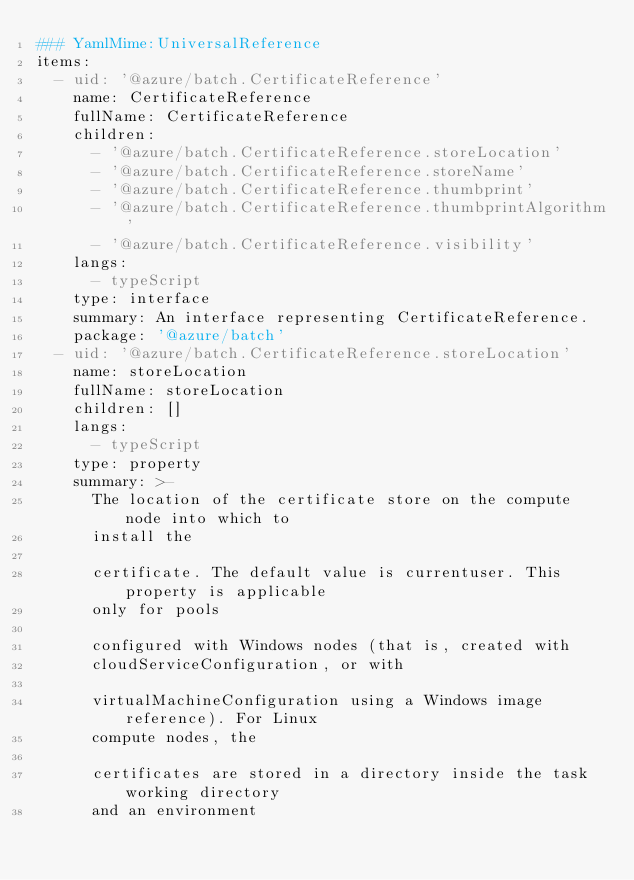Convert code to text. <code><loc_0><loc_0><loc_500><loc_500><_YAML_>### YamlMime:UniversalReference
items:
  - uid: '@azure/batch.CertificateReference'
    name: CertificateReference
    fullName: CertificateReference
    children:
      - '@azure/batch.CertificateReference.storeLocation'
      - '@azure/batch.CertificateReference.storeName'
      - '@azure/batch.CertificateReference.thumbprint'
      - '@azure/batch.CertificateReference.thumbprintAlgorithm'
      - '@azure/batch.CertificateReference.visibility'
    langs:
      - typeScript
    type: interface
    summary: An interface representing CertificateReference.
    package: '@azure/batch'
  - uid: '@azure/batch.CertificateReference.storeLocation'
    name: storeLocation
    fullName: storeLocation
    children: []
    langs:
      - typeScript
    type: property
    summary: >-
      The location of the certificate store on the compute node into which to
      install the

      certificate. The default value is currentuser. This property is applicable
      only for pools

      configured with Windows nodes (that is, created with
      cloudServiceConfiguration, or with

      virtualMachineConfiguration using a Windows image reference). For Linux
      compute nodes, the

      certificates are stored in a directory inside the task working directory
      and an environment
</code> 